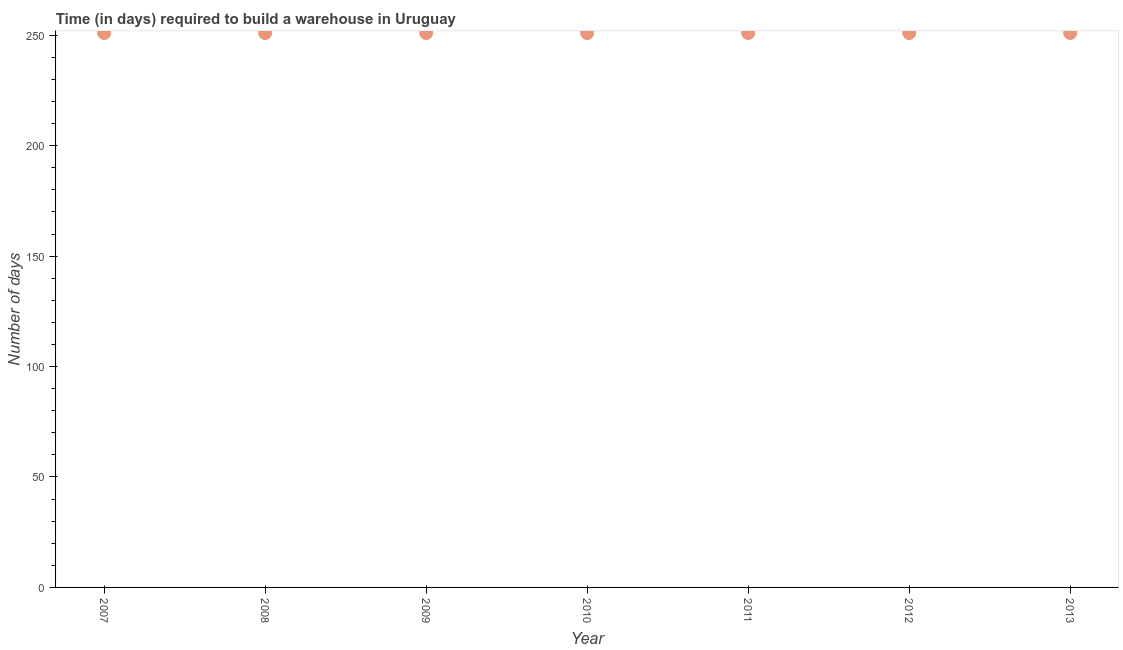What is the time required to build a warehouse in 2012?
Offer a terse response. 251. Across all years, what is the maximum time required to build a warehouse?
Keep it short and to the point. 251. Across all years, what is the minimum time required to build a warehouse?
Your response must be concise. 251. In which year was the time required to build a warehouse maximum?
Ensure brevity in your answer.  2007. In which year was the time required to build a warehouse minimum?
Make the answer very short. 2007. What is the sum of the time required to build a warehouse?
Offer a very short reply. 1757. What is the average time required to build a warehouse per year?
Your response must be concise. 251. What is the median time required to build a warehouse?
Give a very brief answer. 251. In how many years, is the time required to build a warehouse greater than 60 days?
Offer a very short reply. 7. Do a majority of the years between 2007 and 2011 (inclusive) have time required to build a warehouse greater than 110 days?
Ensure brevity in your answer.  Yes. What is the ratio of the time required to build a warehouse in 2008 to that in 2010?
Your response must be concise. 1. Is the difference between the time required to build a warehouse in 2007 and 2008 greater than the difference between any two years?
Your answer should be very brief. Yes. What is the difference between the highest and the lowest time required to build a warehouse?
Provide a succinct answer. 0. In how many years, is the time required to build a warehouse greater than the average time required to build a warehouse taken over all years?
Give a very brief answer. 0. Does the time required to build a warehouse monotonically increase over the years?
Provide a succinct answer. No. How many years are there in the graph?
Offer a terse response. 7. What is the difference between two consecutive major ticks on the Y-axis?
Your response must be concise. 50. Does the graph contain any zero values?
Your answer should be very brief. No. What is the title of the graph?
Offer a very short reply. Time (in days) required to build a warehouse in Uruguay. What is the label or title of the Y-axis?
Your response must be concise. Number of days. What is the Number of days in 2007?
Provide a succinct answer. 251. What is the Number of days in 2008?
Provide a succinct answer. 251. What is the Number of days in 2009?
Offer a terse response. 251. What is the Number of days in 2010?
Ensure brevity in your answer.  251. What is the Number of days in 2011?
Offer a terse response. 251. What is the Number of days in 2012?
Offer a terse response. 251. What is the Number of days in 2013?
Make the answer very short. 251. What is the difference between the Number of days in 2007 and 2010?
Your answer should be very brief. 0. What is the difference between the Number of days in 2007 and 2012?
Provide a short and direct response. 0. What is the difference between the Number of days in 2007 and 2013?
Provide a short and direct response. 0. What is the difference between the Number of days in 2008 and 2011?
Provide a succinct answer. 0. What is the difference between the Number of days in 2008 and 2013?
Keep it short and to the point. 0. What is the difference between the Number of days in 2009 and 2010?
Offer a terse response. 0. What is the difference between the Number of days in 2009 and 2011?
Provide a short and direct response. 0. What is the difference between the Number of days in 2009 and 2013?
Give a very brief answer. 0. What is the difference between the Number of days in 2010 and 2012?
Keep it short and to the point. 0. What is the difference between the Number of days in 2010 and 2013?
Offer a very short reply. 0. What is the difference between the Number of days in 2012 and 2013?
Your response must be concise. 0. What is the ratio of the Number of days in 2007 to that in 2008?
Your response must be concise. 1. What is the ratio of the Number of days in 2007 to that in 2009?
Your answer should be compact. 1. What is the ratio of the Number of days in 2007 to that in 2010?
Offer a terse response. 1. What is the ratio of the Number of days in 2007 to that in 2011?
Your answer should be compact. 1. What is the ratio of the Number of days in 2007 to that in 2012?
Offer a very short reply. 1. What is the ratio of the Number of days in 2007 to that in 2013?
Your answer should be very brief. 1. What is the ratio of the Number of days in 2008 to that in 2010?
Offer a very short reply. 1. What is the ratio of the Number of days in 2008 to that in 2011?
Your answer should be very brief. 1. What is the ratio of the Number of days in 2008 to that in 2012?
Make the answer very short. 1. What is the ratio of the Number of days in 2008 to that in 2013?
Give a very brief answer. 1. What is the ratio of the Number of days in 2009 to that in 2012?
Ensure brevity in your answer.  1. What is the ratio of the Number of days in 2010 to that in 2011?
Your answer should be very brief. 1. What is the ratio of the Number of days in 2010 to that in 2012?
Your answer should be compact. 1. What is the ratio of the Number of days in 2010 to that in 2013?
Offer a terse response. 1. What is the ratio of the Number of days in 2011 to that in 2012?
Keep it short and to the point. 1. What is the ratio of the Number of days in 2011 to that in 2013?
Offer a terse response. 1. What is the ratio of the Number of days in 2012 to that in 2013?
Your answer should be compact. 1. 